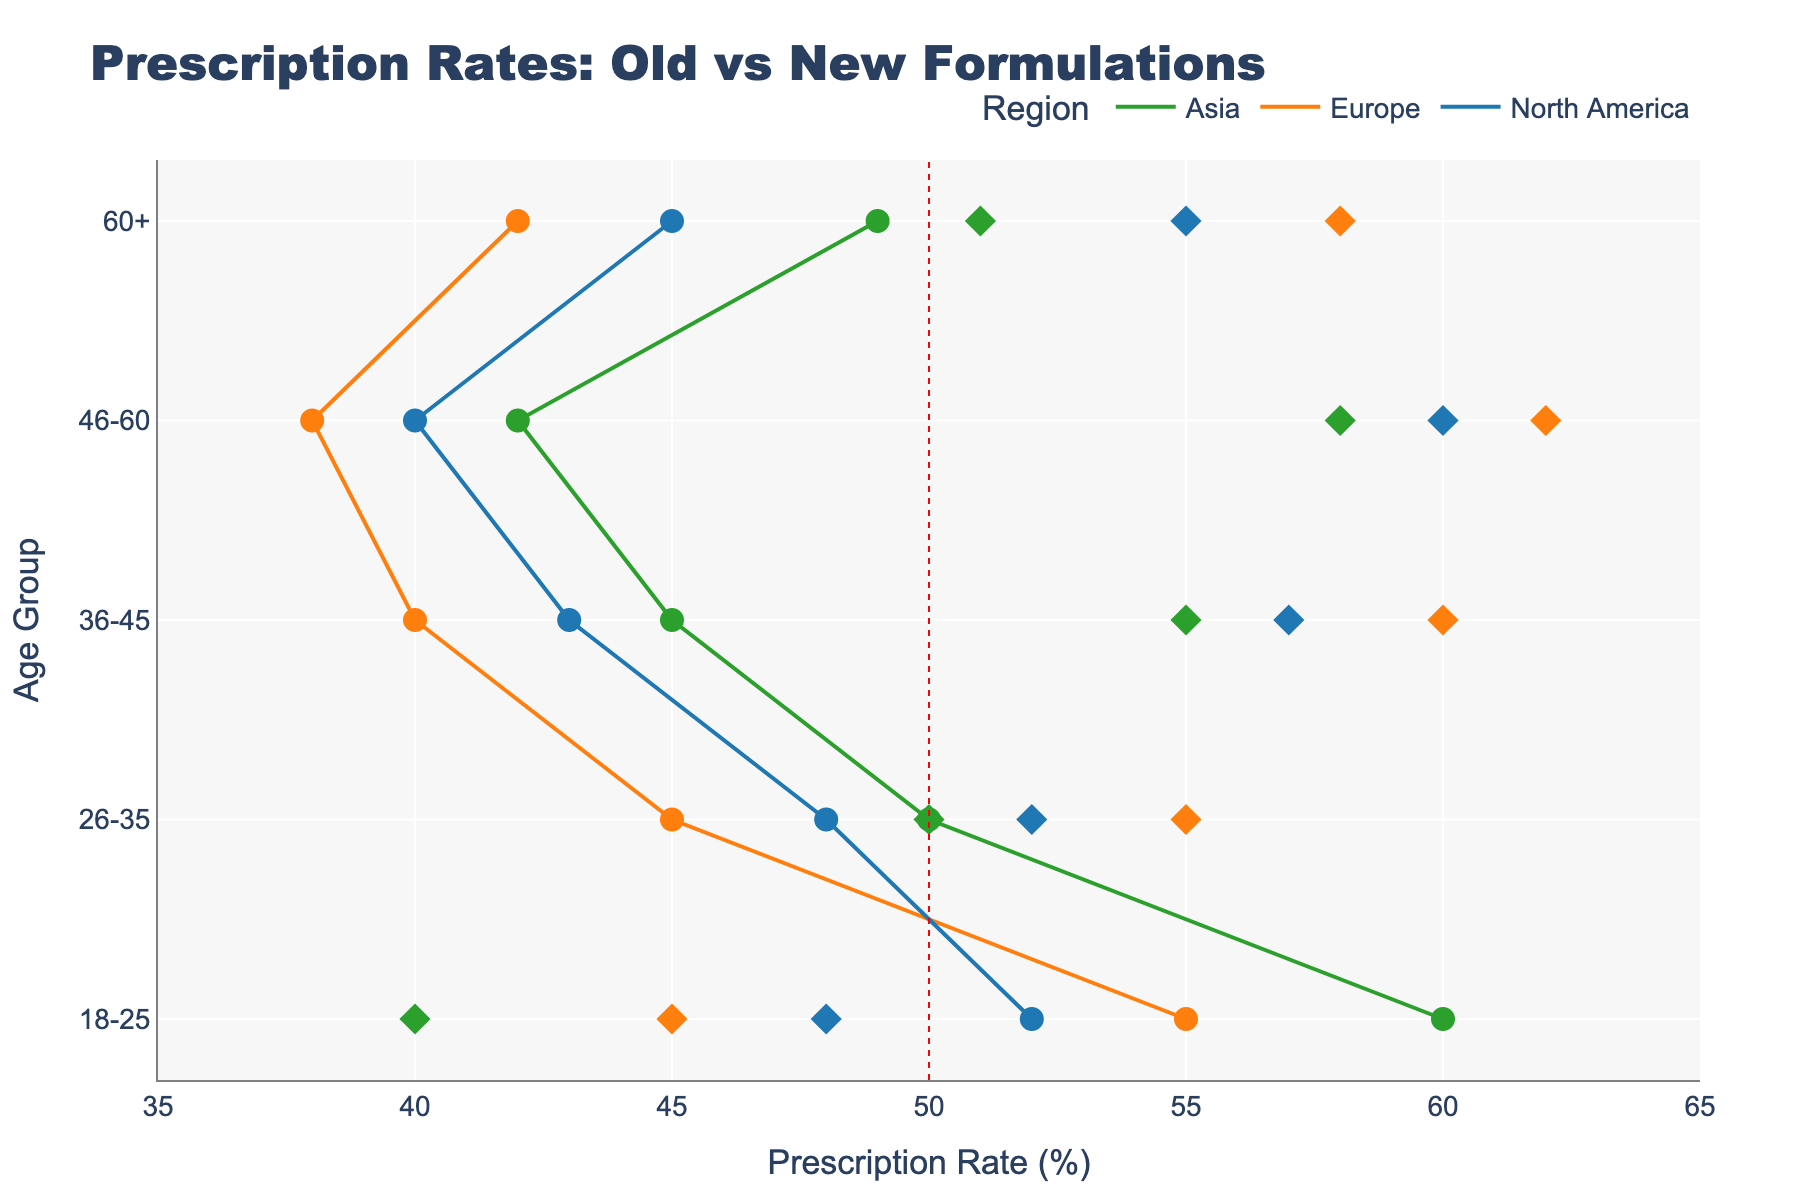What are the prescription rates for the old formulation among the 18-25 age group in Asia? The dumbbell plot shows the prescription rates for both old and new formulations across various regions and age groups. For Asia, in the 18-25 age group, locate the circle (old formulation) on the x-axis.
Answer: 60% What is the difference in prescription rates between old and new formulations for the 46-60 age group in North America? For the 46-60 age group in North America, find the x-axis values for both the old and new formulations (old: 40%, new: 60%) and calculate the difference (60 - 40).
Answer: 20% Which region shows the highest new formulation prescription rate for the 36-45 age group? Check the diamond markers (representing new formulations) for the 36-45 age group across all regions. Europe has the highest rate at 60%.
Answer: Europe For the 60+ age group in Europe, is the prescription rate for the old formulation above or below 45%? Look at the prescription rate for the old formulation in Europe for the 60+ age group. It is shown as a circle, and the rate is 42%, which is below 45%.
Answer: Below How many regions show a higher prescription rate for the new formulation than the old formulation for the 26-35 age group? Count the regions where the diamond marker (new formulation) is to the right of the circle marker (old formulation) for the 26-35 age group. North America and Europe are the two regions.
Answer: 2 